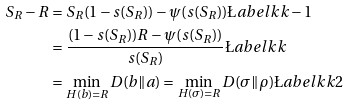Convert formula to latex. <formula><loc_0><loc_0><loc_500><loc_500>S _ { R } - R & = S _ { R } ( 1 - s ( S _ { R } ) ) - \psi ( s ( S _ { R } ) ) \L a b e l { k k - 1 } \\ & = \frac { ( 1 - s ( S _ { R } ) ) R - \psi ( s ( S _ { R } ) ) } { s ( S _ { R } ) } \L a b e l { k k } \\ & = \min _ { H ( { b } ) = R } D ( { b } \| { a } ) = \min _ { H ( \sigma ) = R } D ( \sigma \| \rho ) \L a b e l { k k 2 }</formula> 